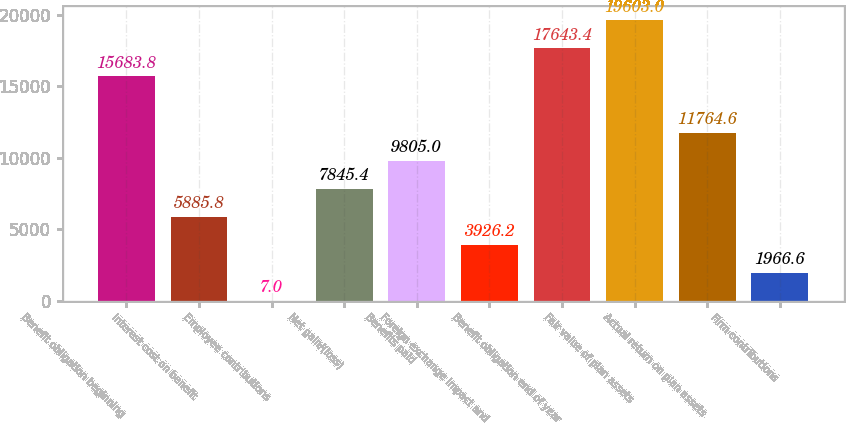Convert chart to OTSL. <chart><loc_0><loc_0><loc_500><loc_500><bar_chart><fcel>Benefit obligation beginning<fcel>Interest cost on benefit<fcel>Employee contributions<fcel>Net gain/(loss)<fcel>Benefits paid<fcel>Foreign exchange impact and<fcel>Benefit obligation end of year<fcel>Fair value of plan assets<fcel>Actual return on plan assets<fcel>Firm contributions<nl><fcel>15683.8<fcel>5885.8<fcel>7<fcel>7845.4<fcel>9805<fcel>3926.2<fcel>17643.4<fcel>19603<fcel>11764.6<fcel>1966.6<nl></chart> 